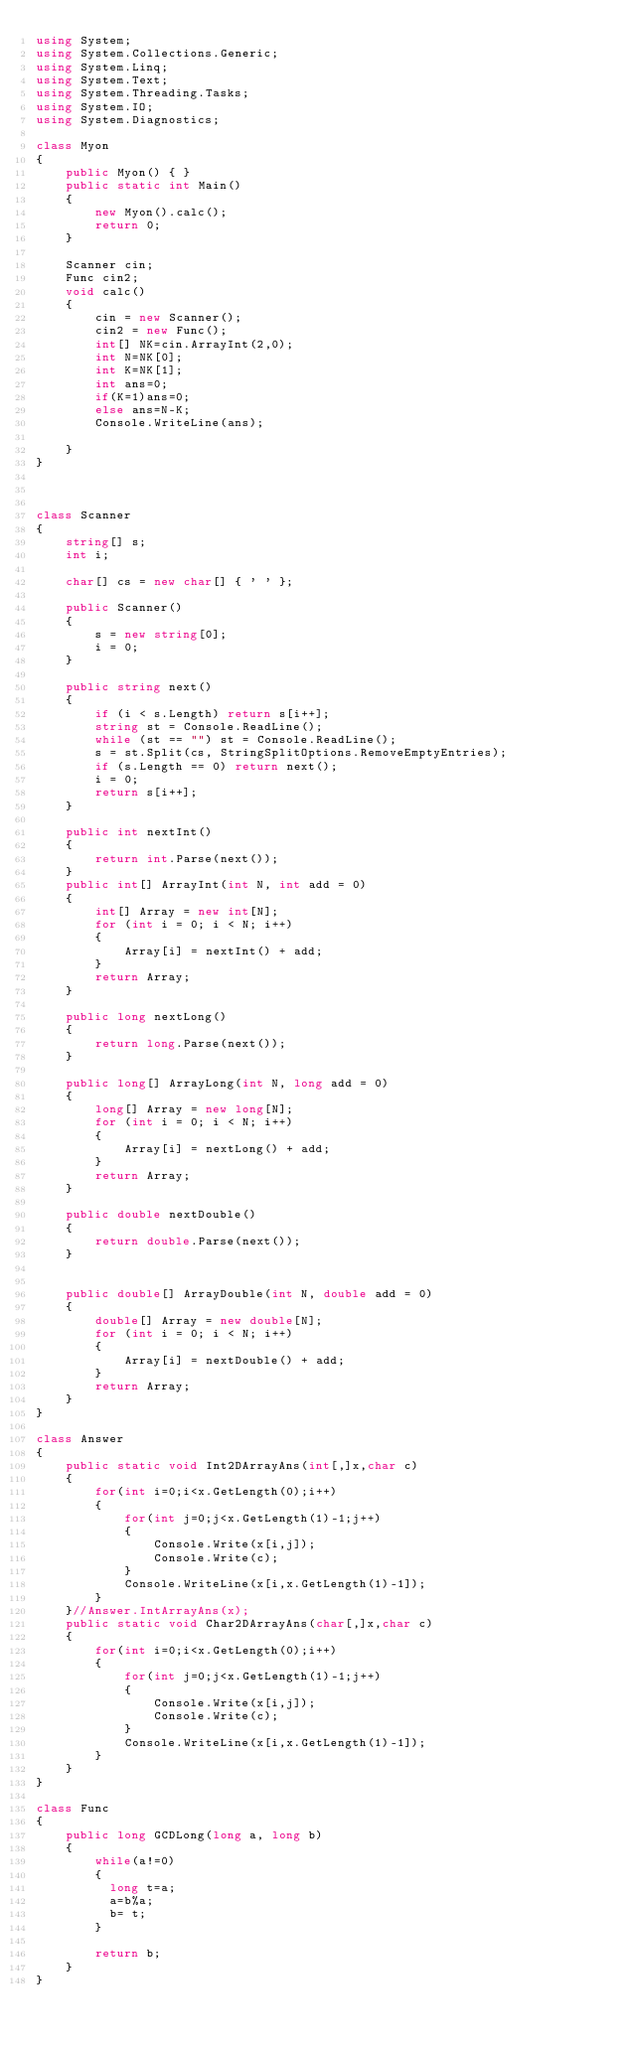Convert code to text. <code><loc_0><loc_0><loc_500><loc_500><_C#_>using System;
using System.Collections.Generic;
using System.Linq;
using System.Text;
using System.Threading.Tasks;
using System.IO;
using System.Diagnostics;

class Myon
{
    public Myon() { }
    public static int Main()
    {
        new Myon().calc();
        return 0;
    }

    Scanner cin;
    Func cin2;
    void calc()
    {
        cin = new Scanner();
        cin2 = new Func();
        int[] NK=cin.ArrayInt(2,0);
        int N=NK[0];
        int K=NK[1];
        int ans=0;
        if(K=1)ans=0;
        else ans=N-K;
        Console.WriteLine(ans);
        
    }
}



class Scanner
{
    string[] s;
    int i;

    char[] cs = new char[] { ' ' };

    public Scanner()
    {
        s = new string[0];
        i = 0;
    }

    public string next()
    {
        if (i < s.Length) return s[i++];
        string st = Console.ReadLine();
        while (st == "") st = Console.ReadLine();
        s = st.Split(cs, StringSplitOptions.RemoveEmptyEntries);
        if (s.Length == 0) return next();
        i = 0;
        return s[i++];
    }

    public int nextInt()
    {
        return int.Parse(next());
    }
    public int[] ArrayInt(int N, int add = 0)
    {
        int[] Array = new int[N];
        for (int i = 0; i < N; i++)
        {
            Array[i] = nextInt() + add;
        }
        return Array;
    }

    public long nextLong()
    {
        return long.Parse(next());
    }

    public long[] ArrayLong(int N, long add = 0)
    {
        long[] Array = new long[N];
        for (int i = 0; i < N; i++)
        {
            Array[i] = nextLong() + add;
        }
        return Array;
    }

    public double nextDouble()
    {
        return double.Parse(next());
    }


    public double[] ArrayDouble(int N, double add = 0)
    {
        double[] Array = new double[N];
        for (int i = 0; i < N; i++)
        {
            Array[i] = nextDouble() + add;
        }
        return Array;
    }
}

class Answer
{
    public static void Int2DArrayAns(int[,]x,char c)
    {
        for(int i=0;i<x.GetLength(0);i++)
        {
            for(int j=0;j<x.GetLength(1)-1;j++)
            {
                Console.Write(x[i,j]);
                Console.Write(c);
            }
            Console.WriteLine(x[i,x.GetLength(1)-1]);
        }
    }//Answer.IntArrayAns(x);
    public static void Char2DArrayAns(char[,]x,char c)
    {
        for(int i=0;i<x.GetLength(0);i++)
        {
            for(int j=0;j<x.GetLength(1)-1;j++)
            {
                Console.Write(x[i,j]);
                Console.Write(c);
            }
            Console.WriteLine(x[i,x.GetLength(1)-1]);
        }
    }
}

class Func
{
    public long GCDLong(long a, long b)
    {
        while(a!=0)
        {
          long t=a;
          a=b%a;
          b= t;
        }
      
        return b;        
    }
}</code> 